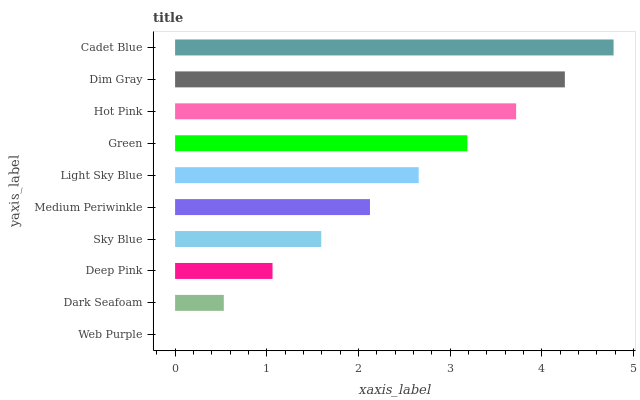Is Web Purple the minimum?
Answer yes or no. Yes. Is Cadet Blue the maximum?
Answer yes or no. Yes. Is Dark Seafoam the minimum?
Answer yes or no. No. Is Dark Seafoam the maximum?
Answer yes or no. No. Is Dark Seafoam greater than Web Purple?
Answer yes or no. Yes. Is Web Purple less than Dark Seafoam?
Answer yes or no. Yes. Is Web Purple greater than Dark Seafoam?
Answer yes or no. No. Is Dark Seafoam less than Web Purple?
Answer yes or no. No. Is Light Sky Blue the high median?
Answer yes or no. Yes. Is Medium Periwinkle the low median?
Answer yes or no. Yes. Is Medium Periwinkle the high median?
Answer yes or no. No. Is Light Sky Blue the low median?
Answer yes or no. No. 